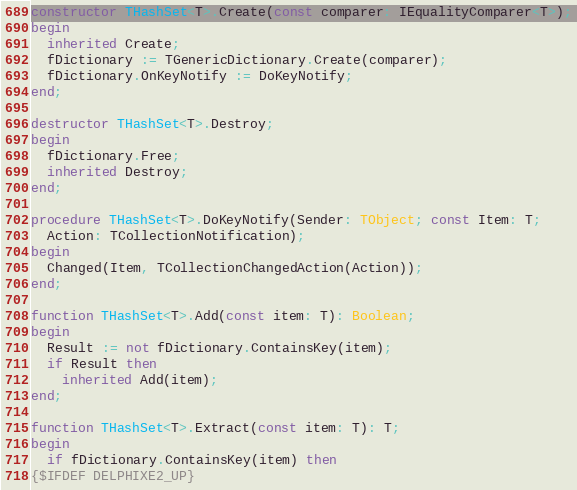<code> <loc_0><loc_0><loc_500><loc_500><_Pascal_>
constructor THashSet<T>.Create(const comparer: IEqualityComparer<T>);
begin
  inherited Create;
  fDictionary := TGenericDictionary.Create(comparer);
  fDictionary.OnKeyNotify := DoKeyNotify;
end;

destructor THashSet<T>.Destroy;
begin
  fDictionary.Free;
  inherited Destroy;
end;

procedure THashSet<T>.DoKeyNotify(Sender: TObject; const Item: T;
  Action: TCollectionNotification);
begin
  Changed(Item, TCollectionChangedAction(Action));
end;

function THashSet<T>.Add(const item: T): Boolean;
begin
  Result := not fDictionary.ContainsKey(item);
  if Result then
    inherited Add(item);
end;

function THashSet<T>.Extract(const item: T): T;
begin
  if fDictionary.ContainsKey(item) then
{$IFDEF DELPHIXE2_UP}</code> 